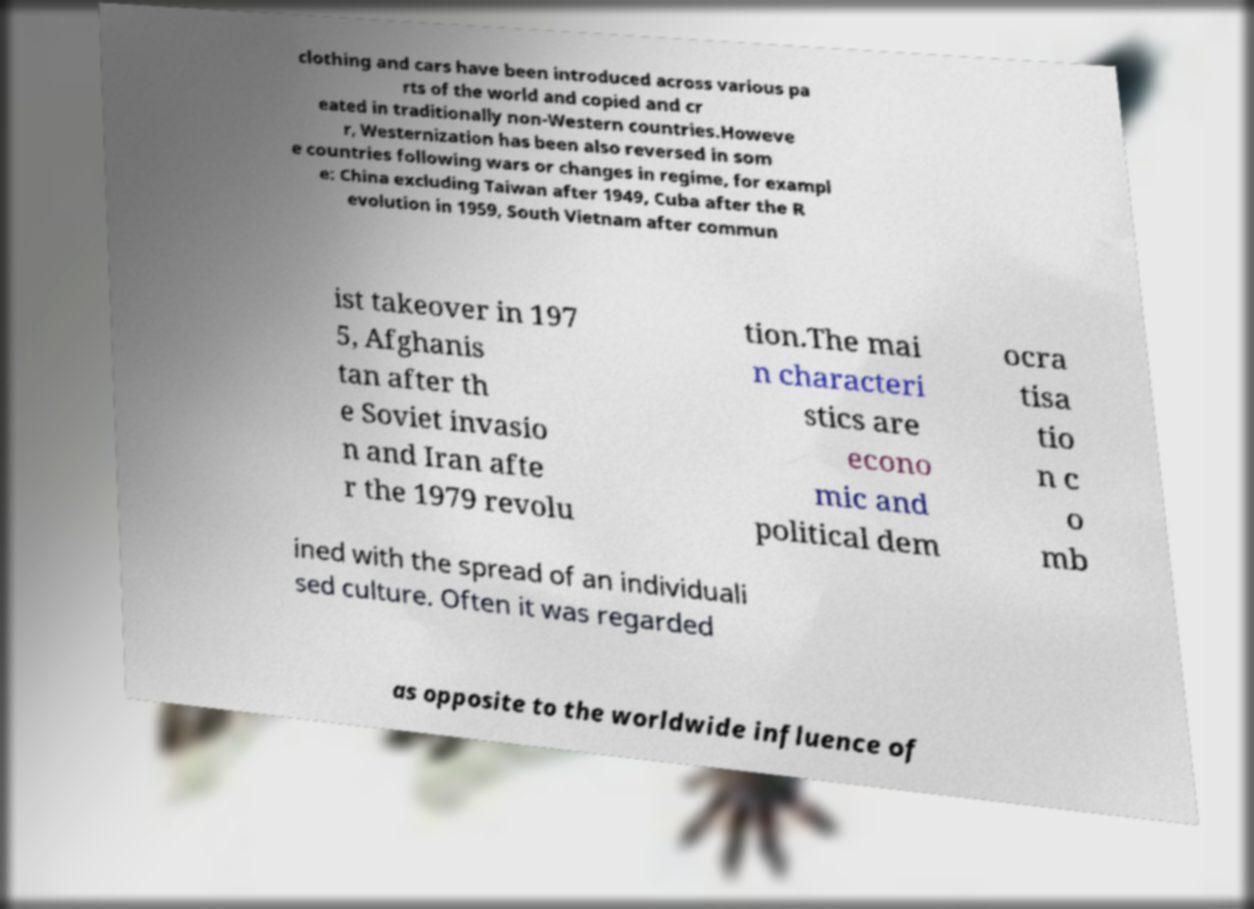Please identify and transcribe the text found in this image. clothing and cars have been introduced across various pa rts of the world and copied and cr eated in traditionally non-Western countries.Howeve r, Westernization has been also reversed in som e countries following wars or changes in regime, for exampl e: China excluding Taiwan after 1949, Cuba after the R evolution in 1959, South Vietnam after commun ist takeover in 197 5, Afghanis tan after th e Soviet invasio n and Iran afte r the 1979 revolu tion.The mai n characteri stics are econo mic and political dem ocra tisa tio n c o mb ined with the spread of an individuali sed culture. Often it was regarded as opposite to the worldwide influence of 